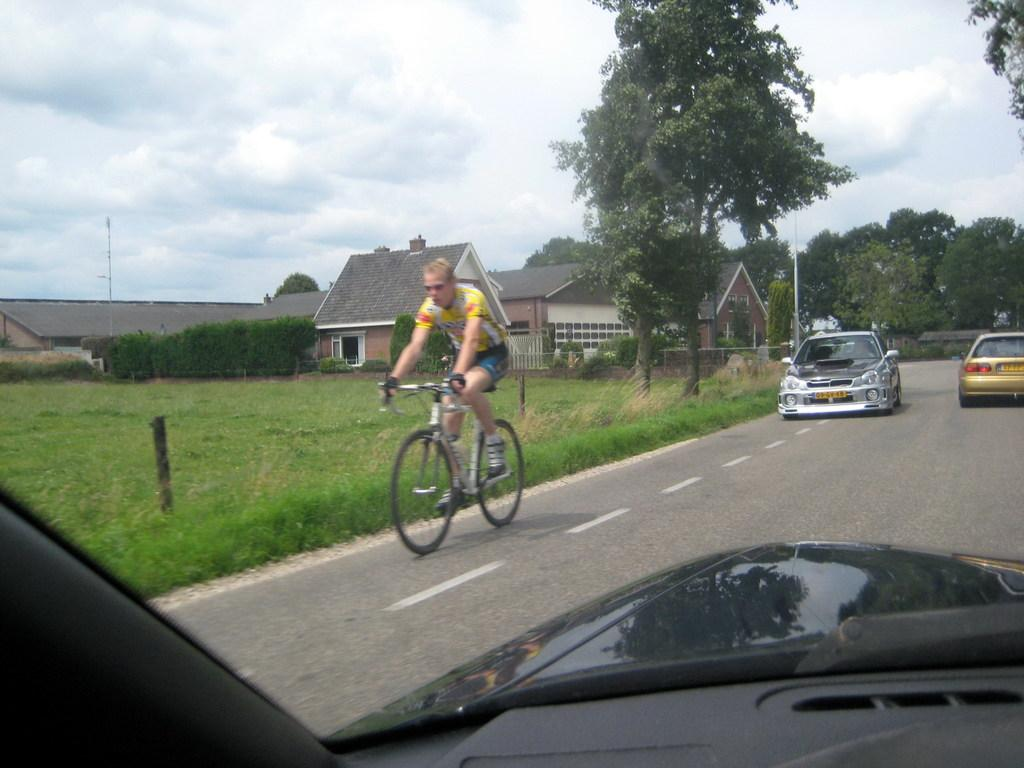What is the person in the image doing? The person in the image is riding a bicycle. What else can be seen on the road in the image? There are vehicles on the road in the image. What type of vegetation is visible in the image? Grass, plants, and trees are present in the image. What can be seen in the background of the image? There are houses, poles, trees, and the sky visible in the background of the image. What is the condition of the sky in the image? The sky is visible in the background of the image, and clouds are present. Can you see the brother of the person riding the bicycle in the image? There is no mention of a brother in the image, so it cannot be determined if the person's brother is present. Is the ocean visible in the image? No, the ocean is not visible in the image; it features a person riding a bicycle, vehicles on the road, and a background with houses, poles, trees, and the sky. 